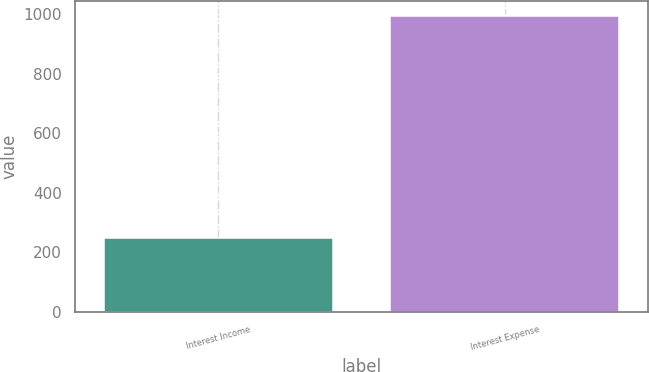<chart> <loc_0><loc_0><loc_500><loc_500><bar_chart><fcel>Interest Income<fcel>Interest Expense<nl><fcel>248<fcel>996<nl></chart> 